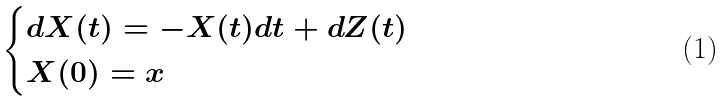Convert formula to latex. <formula><loc_0><loc_0><loc_500><loc_500>\begin{cases} d X ( t ) = - X ( t ) d t + d Z ( t ) \\ X ( 0 ) = x \end{cases}</formula> 